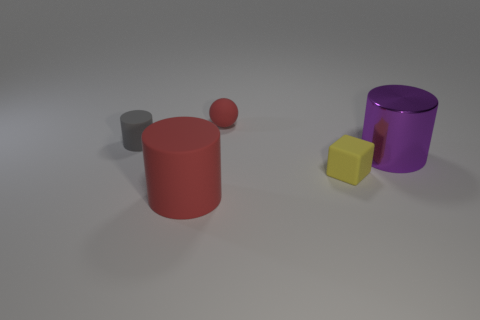What are the different shapes present in the image? The image contains a diverse set of shapes, including two cylinders (one red and one purple), one cube (yellow), and two spheres (one gray and one smaller, also gray). 